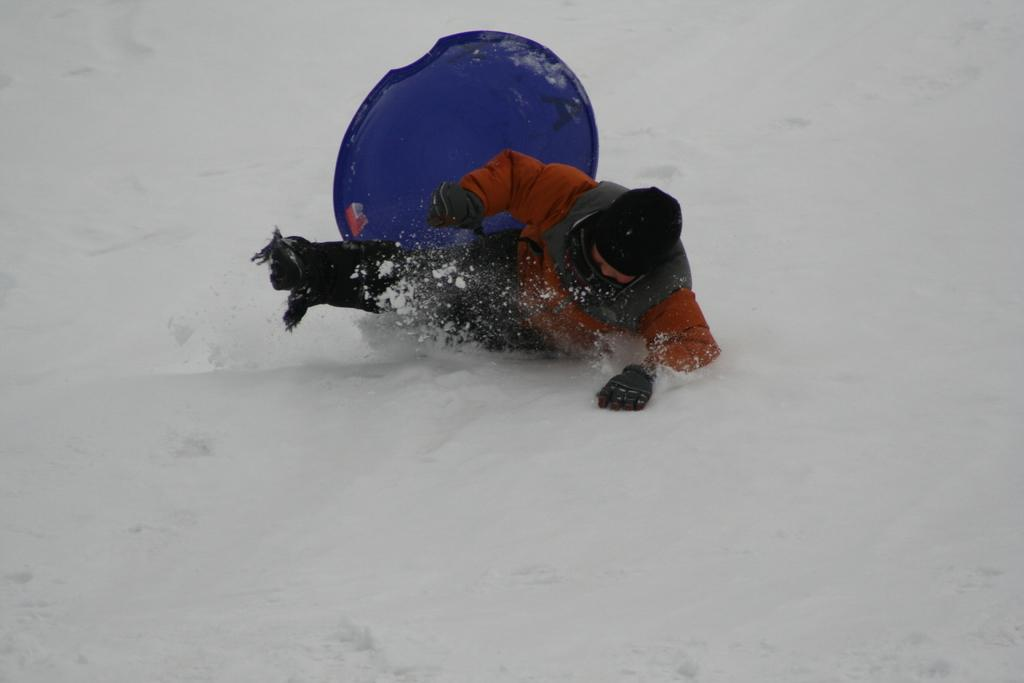What is the primary feature of the landscape in the image? There is snow in the image. Can you describe the person in the snow? There is a person in the snow. What else can be seen in the snow besides the person? There is an object in the snow. How many ants can be seen crawling on the person's tongue in the image? There are no ants or tongues visible in the image; it features a person and an object in the snow. 